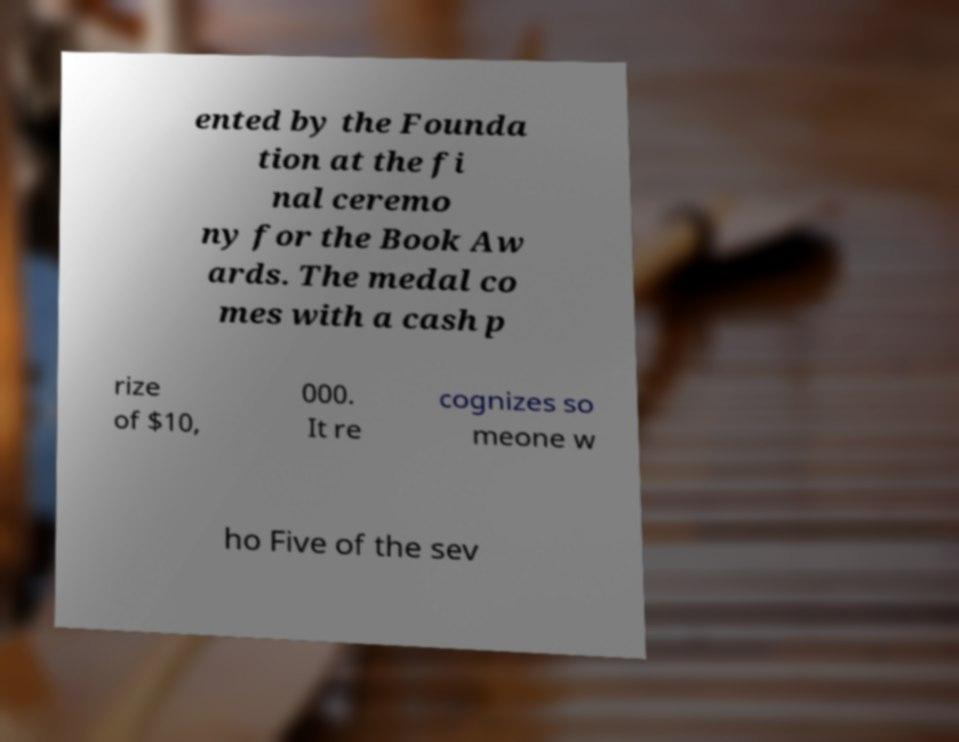Can you accurately transcribe the text from the provided image for me? ented by the Founda tion at the fi nal ceremo ny for the Book Aw ards. The medal co mes with a cash p rize of $10, 000. It re cognizes so meone w ho Five of the sev 